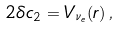Convert formula to latex. <formula><loc_0><loc_0><loc_500><loc_500>2 \delta c _ { 2 } = V _ { \nu _ { e } } ( r ) \, ,</formula> 